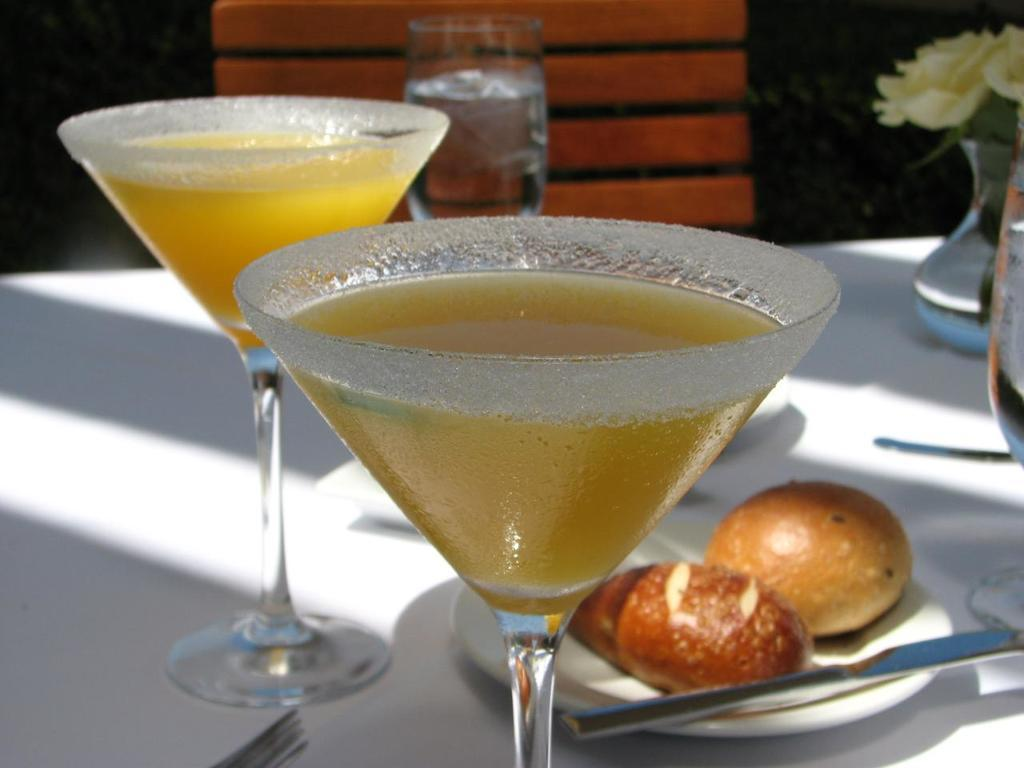What objects are on the table in the image? There are glasses on the table, as well as a plate with food. What utensils are visible in the image? There is a fork and a knife in the image. What additional item can be seen on the table? There is a flower pot on the table. What type of cave is depicted in the background of the image? There is no cave present in the image; it features a table with glasses, a plate with food, utensils, and a flower pot. 